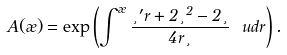Convert formula to latex. <formula><loc_0><loc_0><loc_500><loc_500>A ( \rho ) = \exp \left ( \int ^ { \rho } \frac { \xi ^ { \prime } r + 2 \xi ^ { 2 } - 2 \xi } { 4 r \xi } \ u d r \right ) .</formula> 